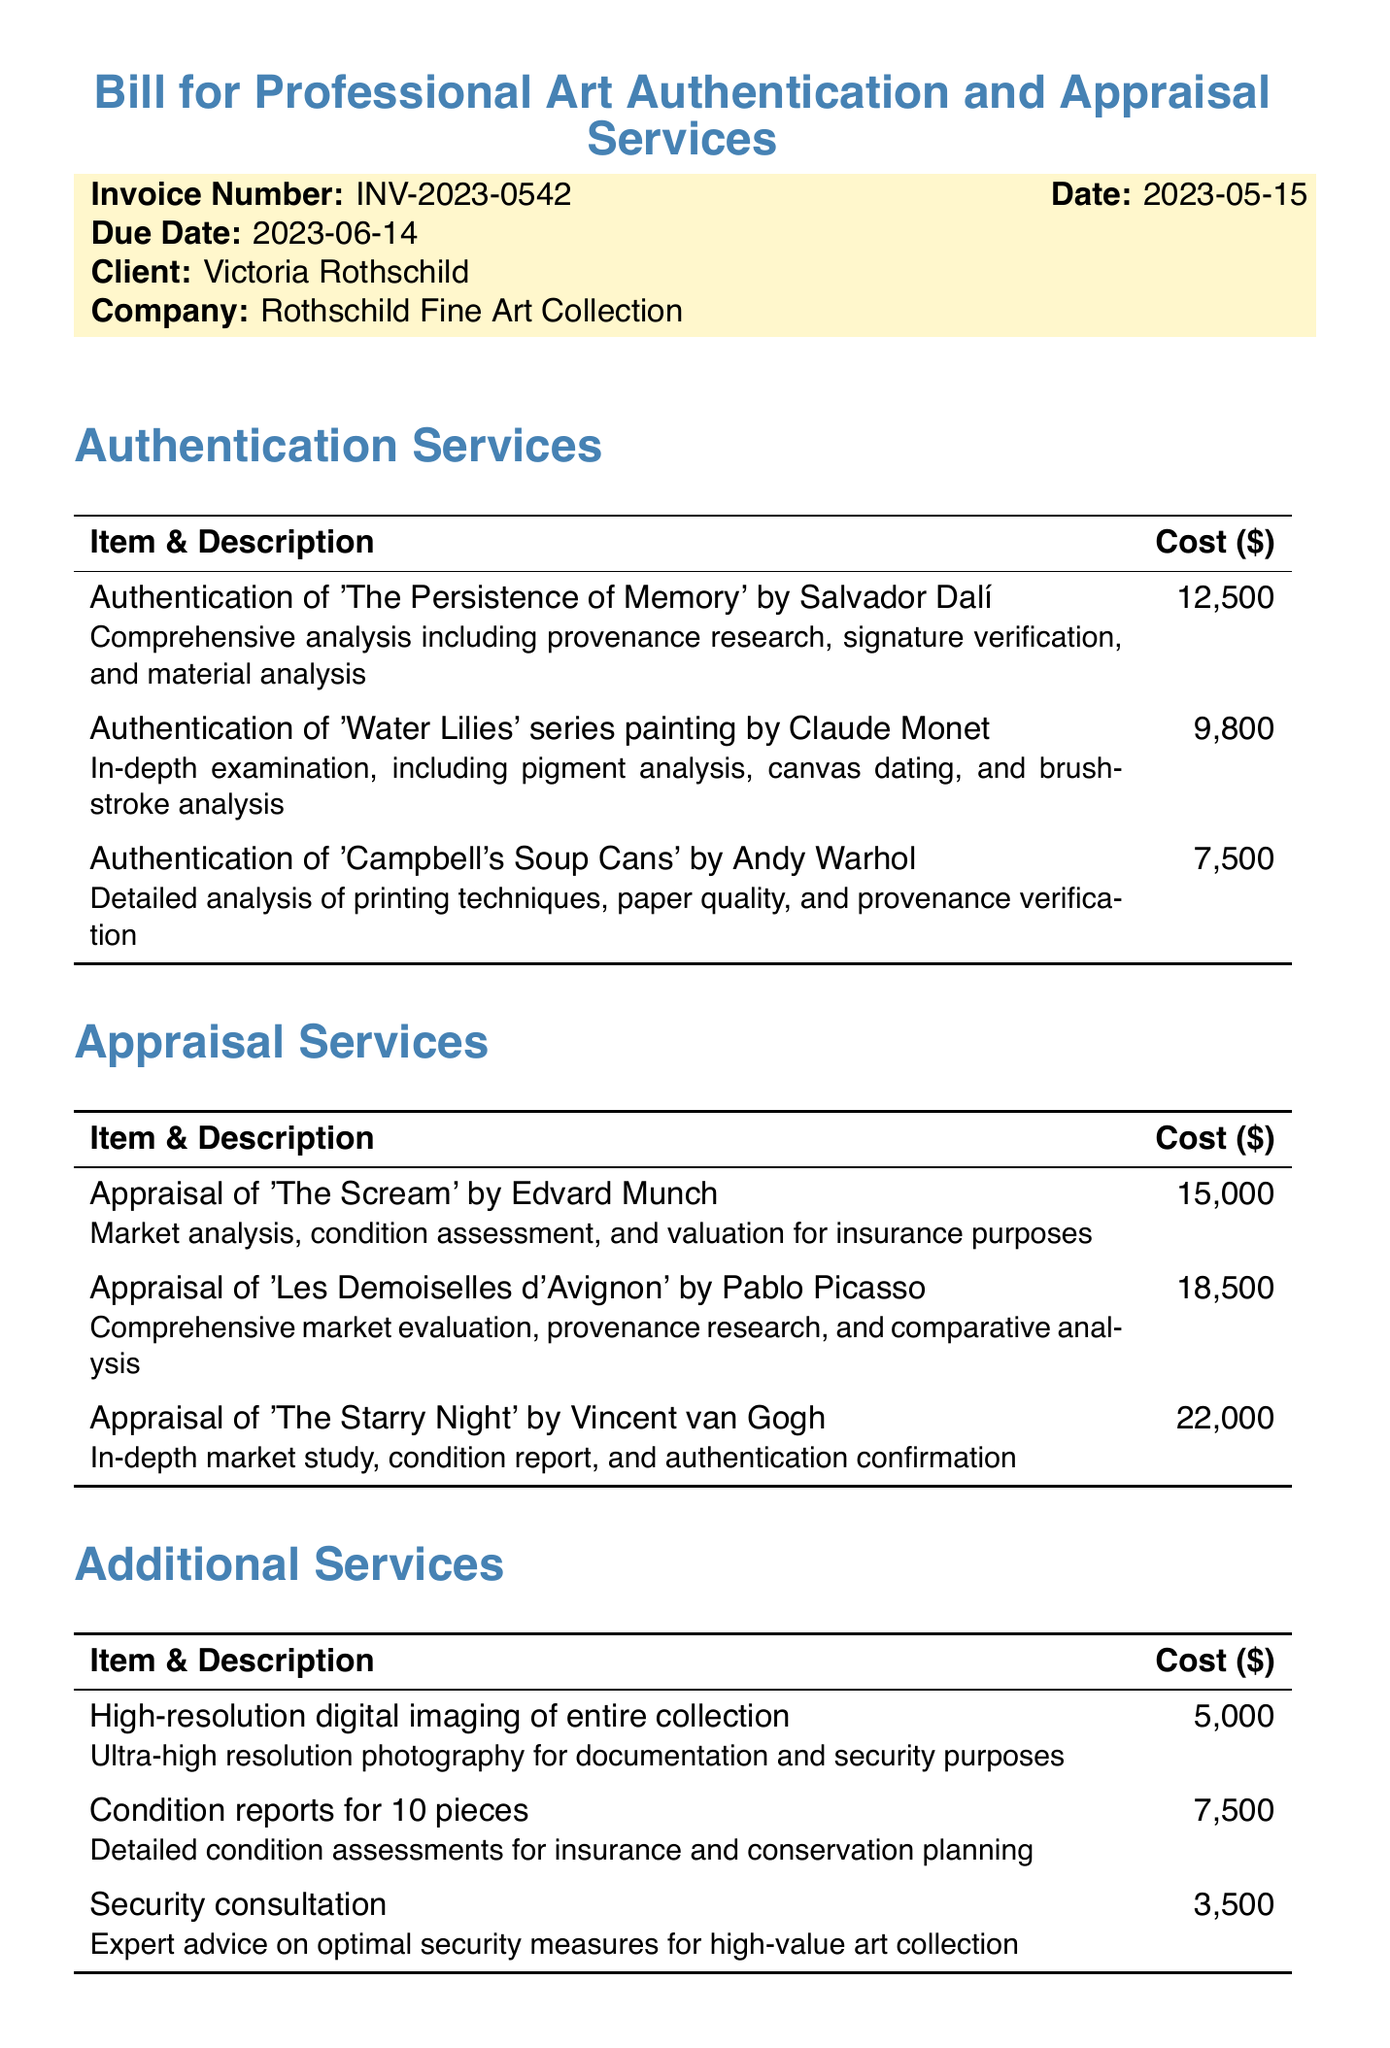What is the invoice number? The invoice number is specifically mentioned in the document, which is INV-2023-0542.
Answer: INV-2023-0542 Who is the client? The client name is provided in the document, which is Victoria Rothschild.
Answer: Victoria Rothschild What is the total cost? The total cost is summarized at the end of the document, which is $101,300.
Answer: $101,300 How much does the authentication of 'The Persistence of Memory' cost? The cost for the authentication of 'The Persistence of Memory' is detailed in the authentication services section, which is $12,500.
Answer: $12,500 What services are included under additional services? The document lists high-resolution digital imaging, condition reports, and security consultation as additional services.
Answer: High-resolution digital imaging, condition reports, security consultation What is the due date for the invoice? The due date is clearly stated in the invoice details, which is June 14, 2023.
Answer: 2023-06-14 What payment methods are accepted? The payment methods mentioned in the document include wire transfer and certified check.
Answer: Wire Transfer, Certified Check How much does the security consultation service cost? The cost for the security consultation is found under additional services in the document, which is $3,500.
Answer: $3,500 What are the payment terms? The payment terms state that it is Net 30, which is mentioned in the total cost section.
Answer: Net 30 